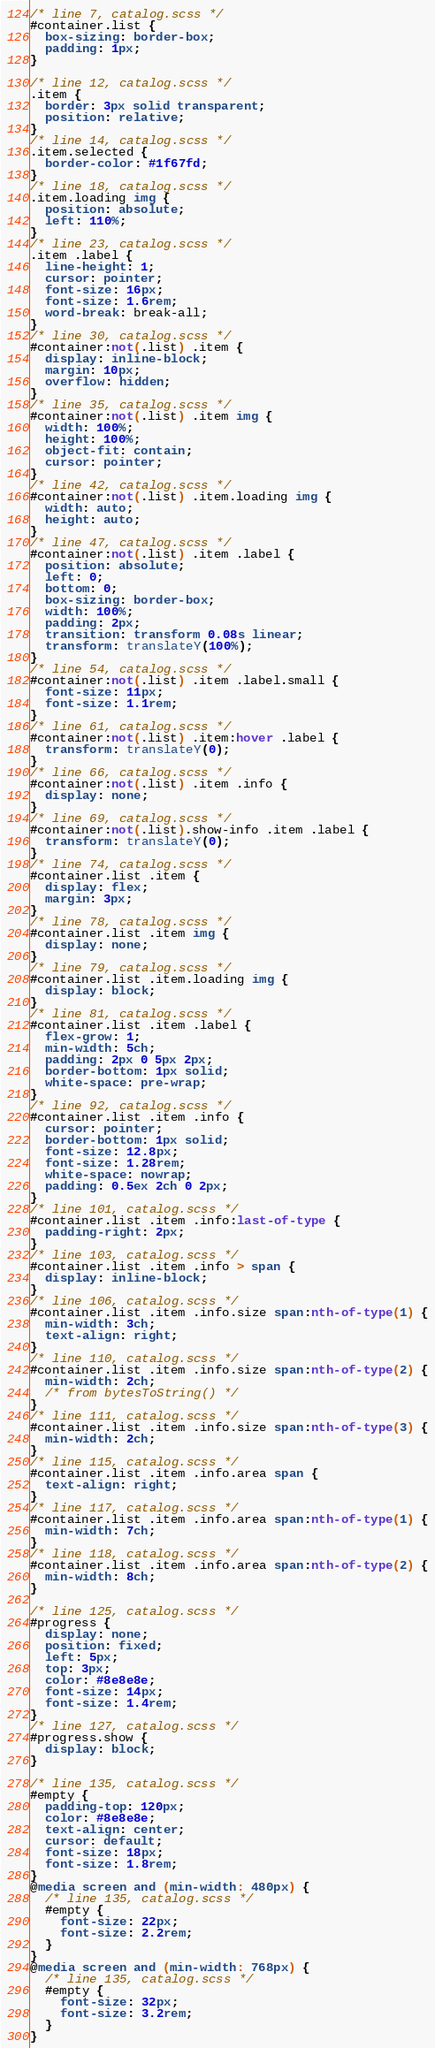<code> <loc_0><loc_0><loc_500><loc_500><_CSS_>/* line 7, catalog.scss */
#container.list {
  box-sizing: border-box;
  padding: 1px;
}

/* line 12, catalog.scss */
.item {
  border: 3px solid transparent;
  position: relative;
}
/* line 14, catalog.scss */
.item.selected {
  border-color: #1f67fd;
}
/* line 18, catalog.scss */
.item.loading img {
  position: absolute;
  left: 110%;
}
/* line 23, catalog.scss */
.item .label {
  line-height: 1;
  cursor: pointer;
  font-size: 16px;
  font-size: 1.6rem;
  word-break: break-all;
}
/* line 30, catalog.scss */
#container:not(.list) .item {
  display: inline-block;
  margin: 10px;
  overflow: hidden;
}
/* line 35, catalog.scss */
#container:not(.list) .item img {
  width: 100%;
  height: 100%;
  object-fit: contain;
  cursor: pointer;
}
/* line 42, catalog.scss */
#container:not(.list) .item.loading img {
  width: auto;
  height: auto;
}
/* line 47, catalog.scss */
#container:not(.list) .item .label {
  position: absolute;
  left: 0;
  bottom: 0;
  box-sizing: border-box;
  width: 100%;
  padding: 2px;
  transition: transform 0.08s linear;
  transform: translateY(100%);
}
/* line 54, catalog.scss */
#container:not(.list) .item .label.small {
  font-size: 11px;
  font-size: 1.1rem;
}
/* line 61, catalog.scss */
#container:not(.list) .item:hover .label {
  transform: translateY(0);
}
/* line 66, catalog.scss */
#container:not(.list) .item .info {
  display: none;
}
/* line 69, catalog.scss */
#container:not(.list).show-info .item .label {
  transform: translateY(0);
}
/* line 74, catalog.scss */
#container.list .item {
  display: flex;
  margin: 3px;
}
/* line 78, catalog.scss */
#container.list .item img {
  display: none;
}
/* line 79, catalog.scss */
#container.list .item.loading img {
  display: block;
}
/* line 81, catalog.scss */
#container.list .item .label {
  flex-grow: 1;
  min-width: 5ch;
  padding: 2px 0 5px 2px;
  border-bottom: 1px solid;
  white-space: pre-wrap;
}
/* line 92, catalog.scss */
#container.list .item .info {
  cursor: pointer;
  border-bottom: 1px solid;
  font-size: 12.8px;
  font-size: 1.28rem;
  white-space: nowrap;
  padding: 0.5ex 2ch 0 2px;
}
/* line 101, catalog.scss */
#container.list .item .info:last-of-type {
  padding-right: 2px;
}
/* line 103, catalog.scss */
#container.list .item .info > span {
  display: inline-block;
}
/* line 106, catalog.scss */
#container.list .item .info.size span:nth-of-type(1) {
  min-width: 3ch;
  text-align: right;
}
/* line 110, catalog.scss */
#container.list .item .info.size span:nth-of-type(2) {
  min-width: 2ch;
  /* from bytesToString() */
}
/* line 111, catalog.scss */
#container.list .item .info.size span:nth-of-type(3) {
  min-width: 2ch;
}
/* line 115, catalog.scss */
#container.list .item .info.area span {
  text-align: right;
}
/* line 117, catalog.scss */
#container.list .item .info.area span:nth-of-type(1) {
  min-width: 7ch;
}
/* line 118, catalog.scss */
#container.list .item .info.area span:nth-of-type(2) {
  min-width: 8ch;
}

/* line 125, catalog.scss */
#progress {
  display: none;
  position: fixed;
  left: 5px;
  top: 3px;
  color: #8e8e8e;
  font-size: 14px;
  font-size: 1.4rem;
}
/* line 127, catalog.scss */
#progress.show {
  display: block;
}

/* line 135, catalog.scss */
#empty {
  padding-top: 120px;
  color: #8e8e8e;
  text-align: center;
  cursor: default;
  font-size: 18px;
  font-size: 1.8rem;
}
@media screen and (min-width: 480px) {
  /* line 135, catalog.scss */
  #empty {
    font-size: 22px;
    font-size: 2.2rem;
  }
}
@media screen and (min-width: 768px) {
  /* line 135, catalog.scss */
  #empty {
    font-size: 32px;
    font-size: 3.2rem;
  }
}
</code> 